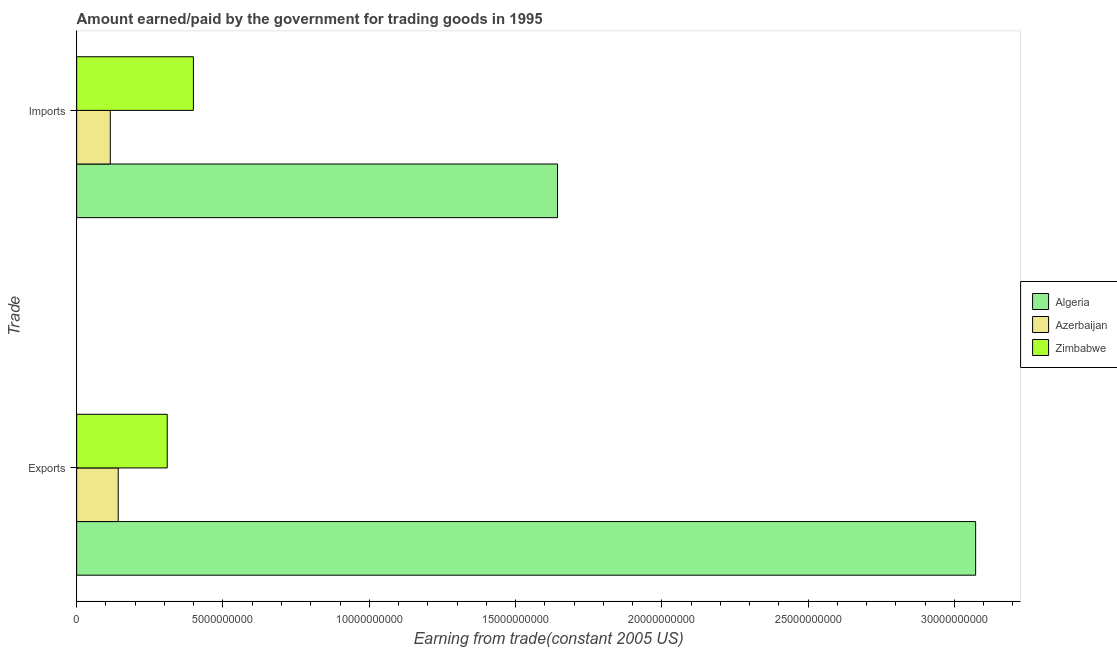How many different coloured bars are there?
Make the answer very short. 3. Are the number of bars per tick equal to the number of legend labels?
Keep it short and to the point. Yes. Are the number of bars on each tick of the Y-axis equal?
Provide a short and direct response. Yes. What is the label of the 1st group of bars from the top?
Your answer should be very brief. Imports. What is the amount paid for imports in Algeria?
Offer a very short reply. 1.64e+1. Across all countries, what is the maximum amount paid for imports?
Offer a terse response. 1.64e+1. Across all countries, what is the minimum amount earned from exports?
Give a very brief answer. 1.42e+09. In which country was the amount earned from exports maximum?
Your answer should be very brief. Algeria. In which country was the amount earned from exports minimum?
Offer a very short reply. Azerbaijan. What is the total amount earned from exports in the graph?
Offer a terse response. 3.52e+1. What is the difference between the amount paid for imports in Zimbabwe and that in Algeria?
Make the answer very short. -1.24e+1. What is the difference between the amount earned from exports in Zimbabwe and the amount paid for imports in Algeria?
Your answer should be compact. -1.33e+1. What is the average amount earned from exports per country?
Offer a very short reply. 1.17e+1. What is the difference between the amount paid for imports and amount earned from exports in Algeria?
Provide a short and direct response. -1.43e+1. In how many countries, is the amount earned from exports greater than 15000000000 US$?
Offer a very short reply. 1. What is the ratio of the amount paid for imports in Azerbaijan to that in Algeria?
Give a very brief answer. 0.07. Is the amount earned from exports in Zimbabwe less than that in Algeria?
Your answer should be very brief. Yes. In how many countries, is the amount paid for imports greater than the average amount paid for imports taken over all countries?
Offer a very short reply. 1. What does the 1st bar from the top in Exports represents?
Your answer should be compact. Zimbabwe. What does the 3rd bar from the bottom in Imports represents?
Your answer should be very brief. Zimbabwe. Are all the bars in the graph horizontal?
Make the answer very short. Yes. Are the values on the major ticks of X-axis written in scientific E-notation?
Provide a succinct answer. No. Does the graph contain any zero values?
Offer a terse response. No. How many legend labels are there?
Ensure brevity in your answer.  3. What is the title of the graph?
Provide a succinct answer. Amount earned/paid by the government for trading goods in 1995. What is the label or title of the X-axis?
Keep it short and to the point. Earning from trade(constant 2005 US). What is the label or title of the Y-axis?
Offer a terse response. Trade. What is the Earning from trade(constant 2005 US) in Algeria in Exports?
Your answer should be compact. 3.07e+1. What is the Earning from trade(constant 2005 US) in Azerbaijan in Exports?
Your answer should be very brief. 1.42e+09. What is the Earning from trade(constant 2005 US) of Zimbabwe in Exports?
Offer a very short reply. 3.10e+09. What is the Earning from trade(constant 2005 US) in Algeria in Imports?
Offer a very short reply. 1.64e+1. What is the Earning from trade(constant 2005 US) in Azerbaijan in Imports?
Make the answer very short. 1.15e+09. What is the Earning from trade(constant 2005 US) in Zimbabwe in Imports?
Offer a very short reply. 3.99e+09. Across all Trade, what is the maximum Earning from trade(constant 2005 US) in Algeria?
Your answer should be compact. 3.07e+1. Across all Trade, what is the maximum Earning from trade(constant 2005 US) of Azerbaijan?
Keep it short and to the point. 1.42e+09. Across all Trade, what is the maximum Earning from trade(constant 2005 US) in Zimbabwe?
Provide a short and direct response. 3.99e+09. Across all Trade, what is the minimum Earning from trade(constant 2005 US) in Algeria?
Your answer should be compact. 1.64e+1. Across all Trade, what is the minimum Earning from trade(constant 2005 US) of Azerbaijan?
Keep it short and to the point. 1.15e+09. Across all Trade, what is the minimum Earning from trade(constant 2005 US) in Zimbabwe?
Make the answer very short. 3.10e+09. What is the total Earning from trade(constant 2005 US) of Algeria in the graph?
Offer a terse response. 4.72e+1. What is the total Earning from trade(constant 2005 US) in Azerbaijan in the graph?
Ensure brevity in your answer.  2.57e+09. What is the total Earning from trade(constant 2005 US) in Zimbabwe in the graph?
Your answer should be very brief. 7.09e+09. What is the difference between the Earning from trade(constant 2005 US) in Algeria in Exports and that in Imports?
Provide a succinct answer. 1.43e+1. What is the difference between the Earning from trade(constant 2005 US) of Azerbaijan in Exports and that in Imports?
Provide a short and direct response. 2.72e+08. What is the difference between the Earning from trade(constant 2005 US) in Zimbabwe in Exports and that in Imports?
Your answer should be compact. -8.95e+08. What is the difference between the Earning from trade(constant 2005 US) in Algeria in Exports and the Earning from trade(constant 2005 US) in Azerbaijan in Imports?
Your response must be concise. 2.96e+1. What is the difference between the Earning from trade(constant 2005 US) in Algeria in Exports and the Earning from trade(constant 2005 US) in Zimbabwe in Imports?
Your response must be concise. 2.67e+1. What is the difference between the Earning from trade(constant 2005 US) in Azerbaijan in Exports and the Earning from trade(constant 2005 US) in Zimbabwe in Imports?
Ensure brevity in your answer.  -2.57e+09. What is the average Earning from trade(constant 2005 US) in Algeria per Trade?
Your answer should be very brief. 2.36e+1. What is the average Earning from trade(constant 2005 US) of Azerbaijan per Trade?
Offer a terse response. 1.28e+09. What is the average Earning from trade(constant 2005 US) of Zimbabwe per Trade?
Offer a terse response. 3.54e+09. What is the difference between the Earning from trade(constant 2005 US) in Algeria and Earning from trade(constant 2005 US) in Azerbaijan in Exports?
Offer a terse response. 2.93e+1. What is the difference between the Earning from trade(constant 2005 US) of Algeria and Earning from trade(constant 2005 US) of Zimbabwe in Exports?
Ensure brevity in your answer.  2.76e+1. What is the difference between the Earning from trade(constant 2005 US) of Azerbaijan and Earning from trade(constant 2005 US) of Zimbabwe in Exports?
Offer a terse response. -1.67e+09. What is the difference between the Earning from trade(constant 2005 US) of Algeria and Earning from trade(constant 2005 US) of Azerbaijan in Imports?
Make the answer very short. 1.53e+1. What is the difference between the Earning from trade(constant 2005 US) in Algeria and Earning from trade(constant 2005 US) in Zimbabwe in Imports?
Provide a succinct answer. 1.24e+1. What is the difference between the Earning from trade(constant 2005 US) of Azerbaijan and Earning from trade(constant 2005 US) of Zimbabwe in Imports?
Ensure brevity in your answer.  -2.84e+09. What is the ratio of the Earning from trade(constant 2005 US) in Algeria in Exports to that in Imports?
Offer a terse response. 1.87. What is the ratio of the Earning from trade(constant 2005 US) of Azerbaijan in Exports to that in Imports?
Offer a terse response. 1.24. What is the ratio of the Earning from trade(constant 2005 US) in Zimbabwe in Exports to that in Imports?
Offer a terse response. 0.78. What is the difference between the highest and the second highest Earning from trade(constant 2005 US) in Algeria?
Ensure brevity in your answer.  1.43e+1. What is the difference between the highest and the second highest Earning from trade(constant 2005 US) of Azerbaijan?
Make the answer very short. 2.72e+08. What is the difference between the highest and the second highest Earning from trade(constant 2005 US) in Zimbabwe?
Keep it short and to the point. 8.95e+08. What is the difference between the highest and the lowest Earning from trade(constant 2005 US) in Algeria?
Make the answer very short. 1.43e+1. What is the difference between the highest and the lowest Earning from trade(constant 2005 US) in Azerbaijan?
Provide a short and direct response. 2.72e+08. What is the difference between the highest and the lowest Earning from trade(constant 2005 US) of Zimbabwe?
Give a very brief answer. 8.95e+08. 